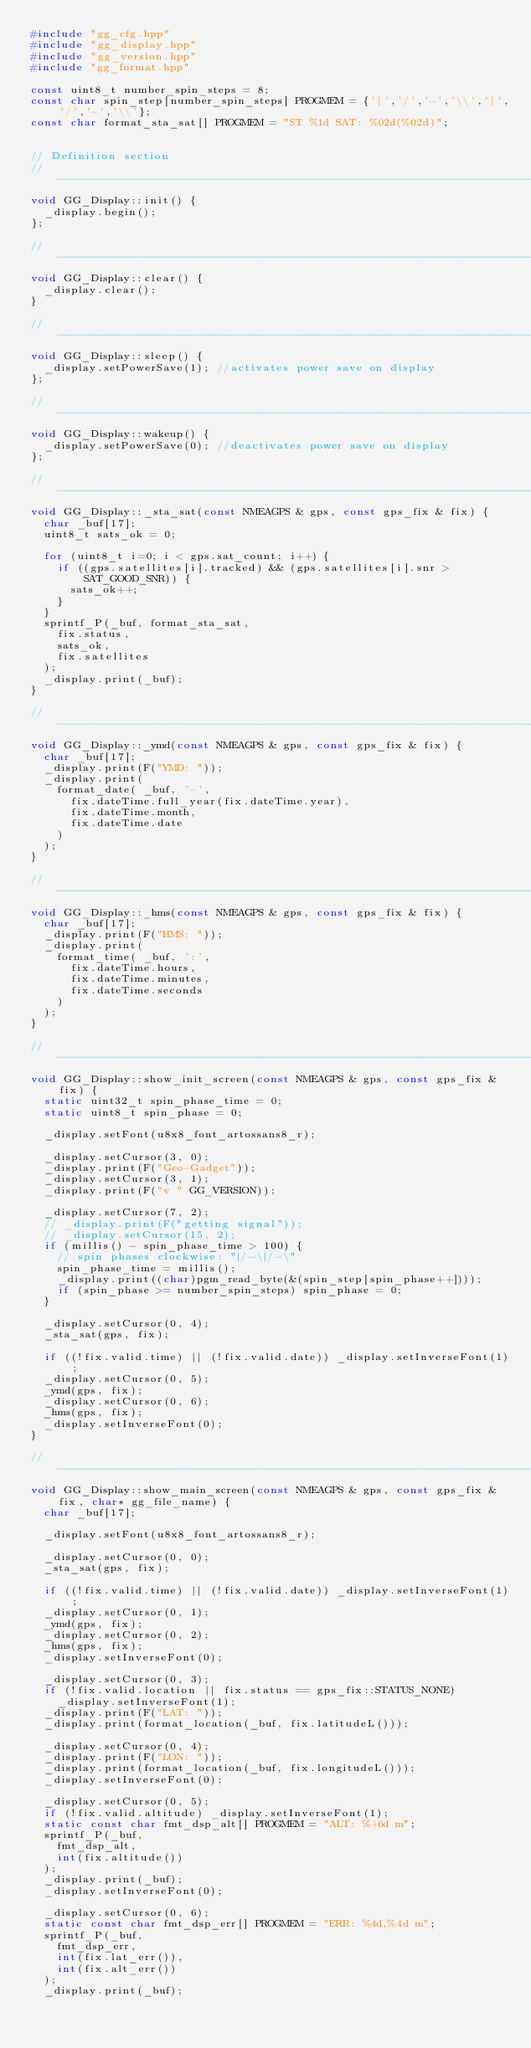<code> <loc_0><loc_0><loc_500><loc_500><_C++_>#include "gg_cfg.hpp"
#include "gg_display.hpp"
#include "gg_version.hpp"
#include "gg_format.hpp"

const uint8_t number_spin_steps = 8;
const char spin_step[number_spin_steps] PROGMEM = {'|','/','-','\\','|','/','-','\\'};
const char format_sta_sat[] PROGMEM = "ST %1d SAT: %02d(%02d)";


// Definition section
//-----------------------------------------------------------------------------
void GG_Display::init() {
  _display.begin();
};

//-----------------------------------------------------------------------------
void GG_Display::clear() {
  _display.clear();
}

//-----------------------------------------------------------------------------
void GG_Display::sleep() {
  _display.setPowerSave(1); //activates power save on display
};

//-----------------------------------------------------------------------------
void GG_Display::wakeup() {
  _display.setPowerSave(0); //deactivates power save on display
};

//-----------------------------------------------------------------------------
void GG_Display::_sta_sat(const NMEAGPS & gps, const gps_fix & fix) {
  char _buf[17];
  uint8_t sats_ok = 0;

  for (uint8_t i=0; i < gps.sat_count; i++) {
    if ((gps.satellites[i].tracked) && (gps.satellites[i].snr > SAT_GOOD_SNR)) {
      sats_ok++;
    }
  }
  sprintf_P(_buf, format_sta_sat,
    fix.status,
    sats_ok,
    fix.satellites
  );
  _display.print(_buf);
}

//-----------------------------------------------------------------------------
void GG_Display::_ymd(const NMEAGPS & gps, const gps_fix & fix) {
  char _buf[17];
  _display.print(F("YMD: "));
  _display.print(
    format_date( _buf, '-',
      fix.dateTime.full_year(fix.dateTime.year),
      fix.dateTime.month,
      fix.dateTime.date
    )
  );
}

//-----------------------------------------------------------------------------
void GG_Display::_hms(const NMEAGPS & gps, const gps_fix & fix) {
  char _buf[17];
  _display.print(F("HMS: "));
  _display.print(
    format_time( _buf, ':',
      fix.dateTime.hours,
      fix.dateTime.minutes,
      fix.dateTime.seconds
    )
  );
}

//-----------------------------------------------------------------------------
void GG_Display::show_init_screen(const NMEAGPS & gps, const gps_fix & fix) {
  static uint32_t spin_phase_time = 0;
  static uint8_t spin_phase = 0;

  _display.setFont(u8x8_font_artossans8_r);

  _display.setCursor(3, 0);
  _display.print(F("Geo-Gadget"));
  _display.setCursor(3, 1);
  _display.print(F("v " GG_VERSION));

  _display.setCursor(7, 2);
  // _display.print(F("getting signal"));
  // _display.setCursor(15, 2);
  if (millis() - spin_phase_time > 100) {
    // spin phases clockwise: "|/-\|/-\"
    spin_phase_time = millis();
    _display.print((char)pgm_read_byte(&(spin_step[spin_phase++])));
    if (spin_phase >= number_spin_steps) spin_phase = 0;
  }

  _display.setCursor(0, 4);
  _sta_sat(gps, fix);

  if ((!fix.valid.time) || (!fix.valid.date)) _display.setInverseFont(1);
  _display.setCursor(0, 5);
  _ymd(gps, fix);
  _display.setCursor(0, 6);
  _hms(gps, fix);
  _display.setInverseFont(0);
}

//-----------------------------------------------------------------------------
void GG_Display::show_main_screen(const NMEAGPS & gps, const gps_fix & fix, char* gg_file_name) {
  char _buf[17];

  _display.setFont(u8x8_font_artossans8_r);

  _display.setCursor(0, 0);
  _sta_sat(gps, fix);

  if ((!fix.valid.time) || (!fix.valid.date)) _display.setInverseFont(1);
  _display.setCursor(0, 1);
  _ymd(gps, fix);
  _display.setCursor(0, 2);
  _hms(gps, fix);
  _display.setInverseFont(0);

  _display.setCursor(0, 3);
  if (!fix.valid.location || fix.status == gps_fix::STATUS_NONE)
    _display.setInverseFont(1);
  _display.print(F("LAT: "));
  _display.print(format_location(_buf, fix.latitudeL()));

  _display.setCursor(0, 4);
  _display.print(F("LON: "));
  _display.print(format_location(_buf, fix.longitudeL()));
  _display.setInverseFont(0);

  _display.setCursor(0, 5);
  if (!fix.valid.altitude) _display.setInverseFont(1);
  static const char fmt_dsp_alt[] PROGMEM = "ALT: %+6d m";
  sprintf_P(_buf,
    fmt_dsp_alt,
    int(fix.altitude())
  );
  _display.print(_buf);
  _display.setInverseFont(0);

  _display.setCursor(0, 6);
  static const char fmt_dsp_err[] PROGMEM = "ERR: %4d,%4d m";
  sprintf_P(_buf,
    fmt_dsp_err,
    int(fix.lat_err()),
    int(fix.alt_err())
  );
  _display.print(_buf);
</code> 